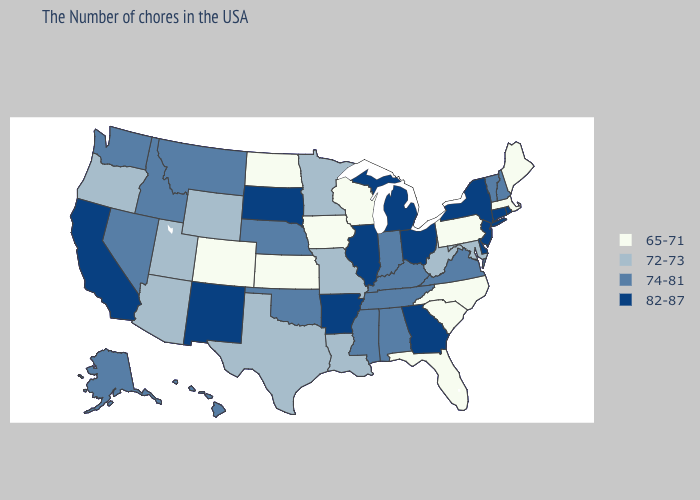Does Nevada have the lowest value in the West?
Answer briefly. No. Among the states that border Montana , does North Dakota have the lowest value?
Quick response, please. Yes. Name the states that have a value in the range 82-87?
Short answer required. Rhode Island, Connecticut, New York, New Jersey, Delaware, Ohio, Georgia, Michigan, Illinois, Arkansas, South Dakota, New Mexico, California. Does South Carolina have the lowest value in the USA?
Concise answer only. Yes. What is the value of Nevada?
Answer briefly. 74-81. Among the states that border Indiana , does Michigan have the lowest value?
Answer briefly. No. What is the value of Minnesota?
Write a very short answer. 72-73. Does New Hampshire have a lower value than Tennessee?
Be succinct. No. Among the states that border Washington , does Oregon have the lowest value?
Write a very short answer. Yes. What is the lowest value in the MidWest?
Be succinct. 65-71. Does North Carolina have a lower value than Colorado?
Answer briefly. No. Which states hav the highest value in the Northeast?
Keep it brief. Rhode Island, Connecticut, New York, New Jersey. Among the states that border Oregon , does California have the lowest value?
Quick response, please. No. Among the states that border Wyoming , which have the lowest value?
Concise answer only. Colorado. What is the lowest value in states that border Idaho?
Concise answer only. 72-73. 